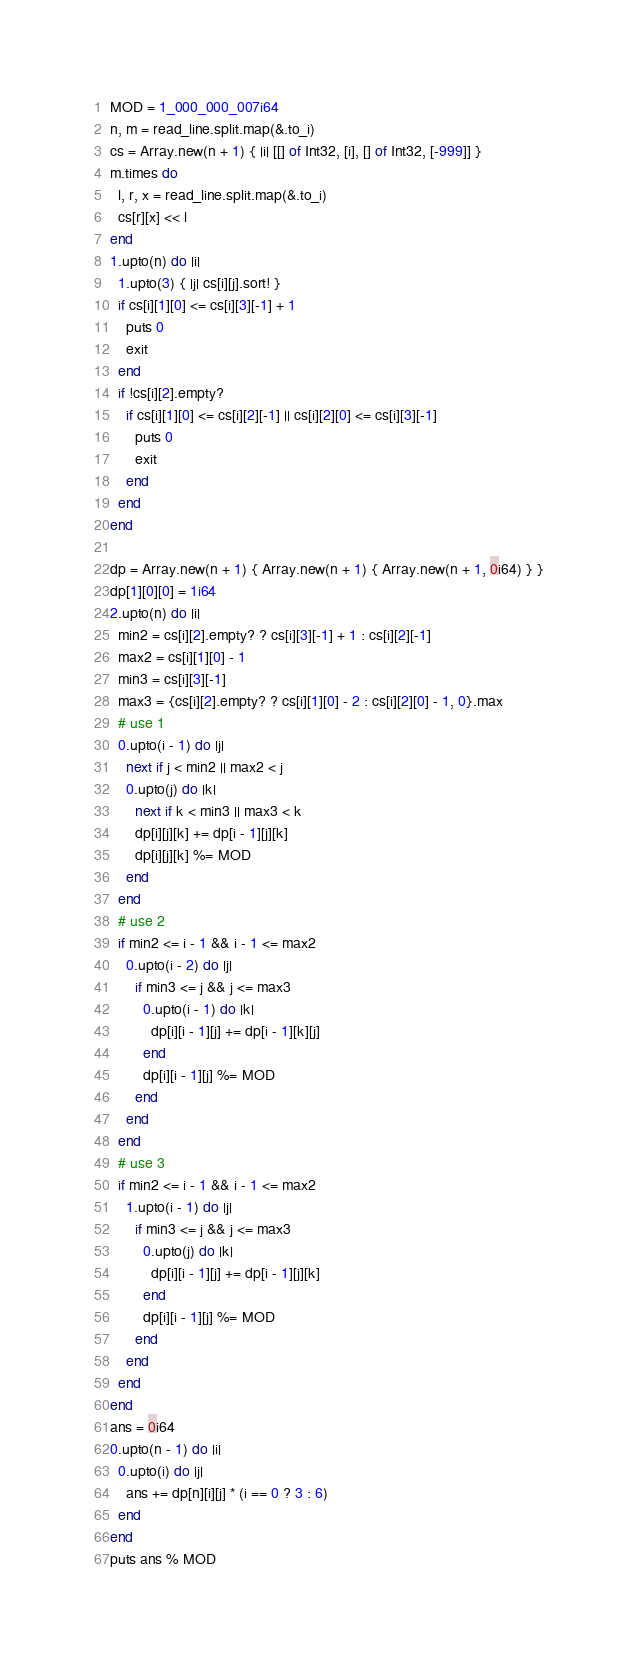Convert code to text. <code><loc_0><loc_0><loc_500><loc_500><_Crystal_>MOD = 1_000_000_007i64
n, m = read_line.split.map(&.to_i)
cs = Array.new(n + 1) { |i| [[] of Int32, [i], [] of Int32, [-999]] }
m.times do
  l, r, x = read_line.split.map(&.to_i)
  cs[r][x] << l
end
1.upto(n) do |i|
  1.upto(3) { |j| cs[i][j].sort! }
  if cs[i][1][0] <= cs[i][3][-1] + 1
    puts 0
    exit
  end
  if !cs[i][2].empty?
    if cs[i][1][0] <= cs[i][2][-1] || cs[i][2][0] <= cs[i][3][-1]
      puts 0
      exit
    end
  end
end

dp = Array.new(n + 1) { Array.new(n + 1) { Array.new(n + 1, 0i64) } }
dp[1][0][0] = 1i64
2.upto(n) do |i|
  min2 = cs[i][2].empty? ? cs[i][3][-1] + 1 : cs[i][2][-1]
  max2 = cs[i][1][0] - 1
  min3 = cs[i][3][-1]
  max3 = {cs[i][2].empty? ? cs[i][1][0] - 2 : cs[i][2][0] - 1, 0}.max
  # use 1
  0.upto(i - 1) do |j|
    next if j < min2 || max2 < j
    0.upto(j) do |k|
      next if k < min3 || max3 < k
      dp[i][j][k] += dp[i - 1][j][k]
      dp[i][j][k] %= MOD
    end
  end
  # use 2
  if min2 <= i - 1 && i - 1 <= max2
    0.upto(i - 2) do |j|
      if min3 <= j && j <= max3
        0.upto(i - 1) do |k|
          dp[i][i - 1][j] += dp[i - 1][k][j]
        end
        dp[i][i - 1][j] %= MOD
      end
    end
  end
  # use 3
  if min2 <= i - 1 && i - 1 <= max2
    1.upto(i - 1) do |j|
      if min3 <= j && j <= max3
        0.upto(j) do |k|
          dp[i][i - 1][j] += dp[i - 1][j][k]
        end
        dp[i][i - 1][j] %= MOD
      end
    end
  end
end
ans = 0i64
0.upto(n - 1) do |i|
  0.upto(i) do |j|
    ans += dp[n][i][j] * (i == 0 ? 3 : 6)
  end
end
puts ans % MOD
</code> 